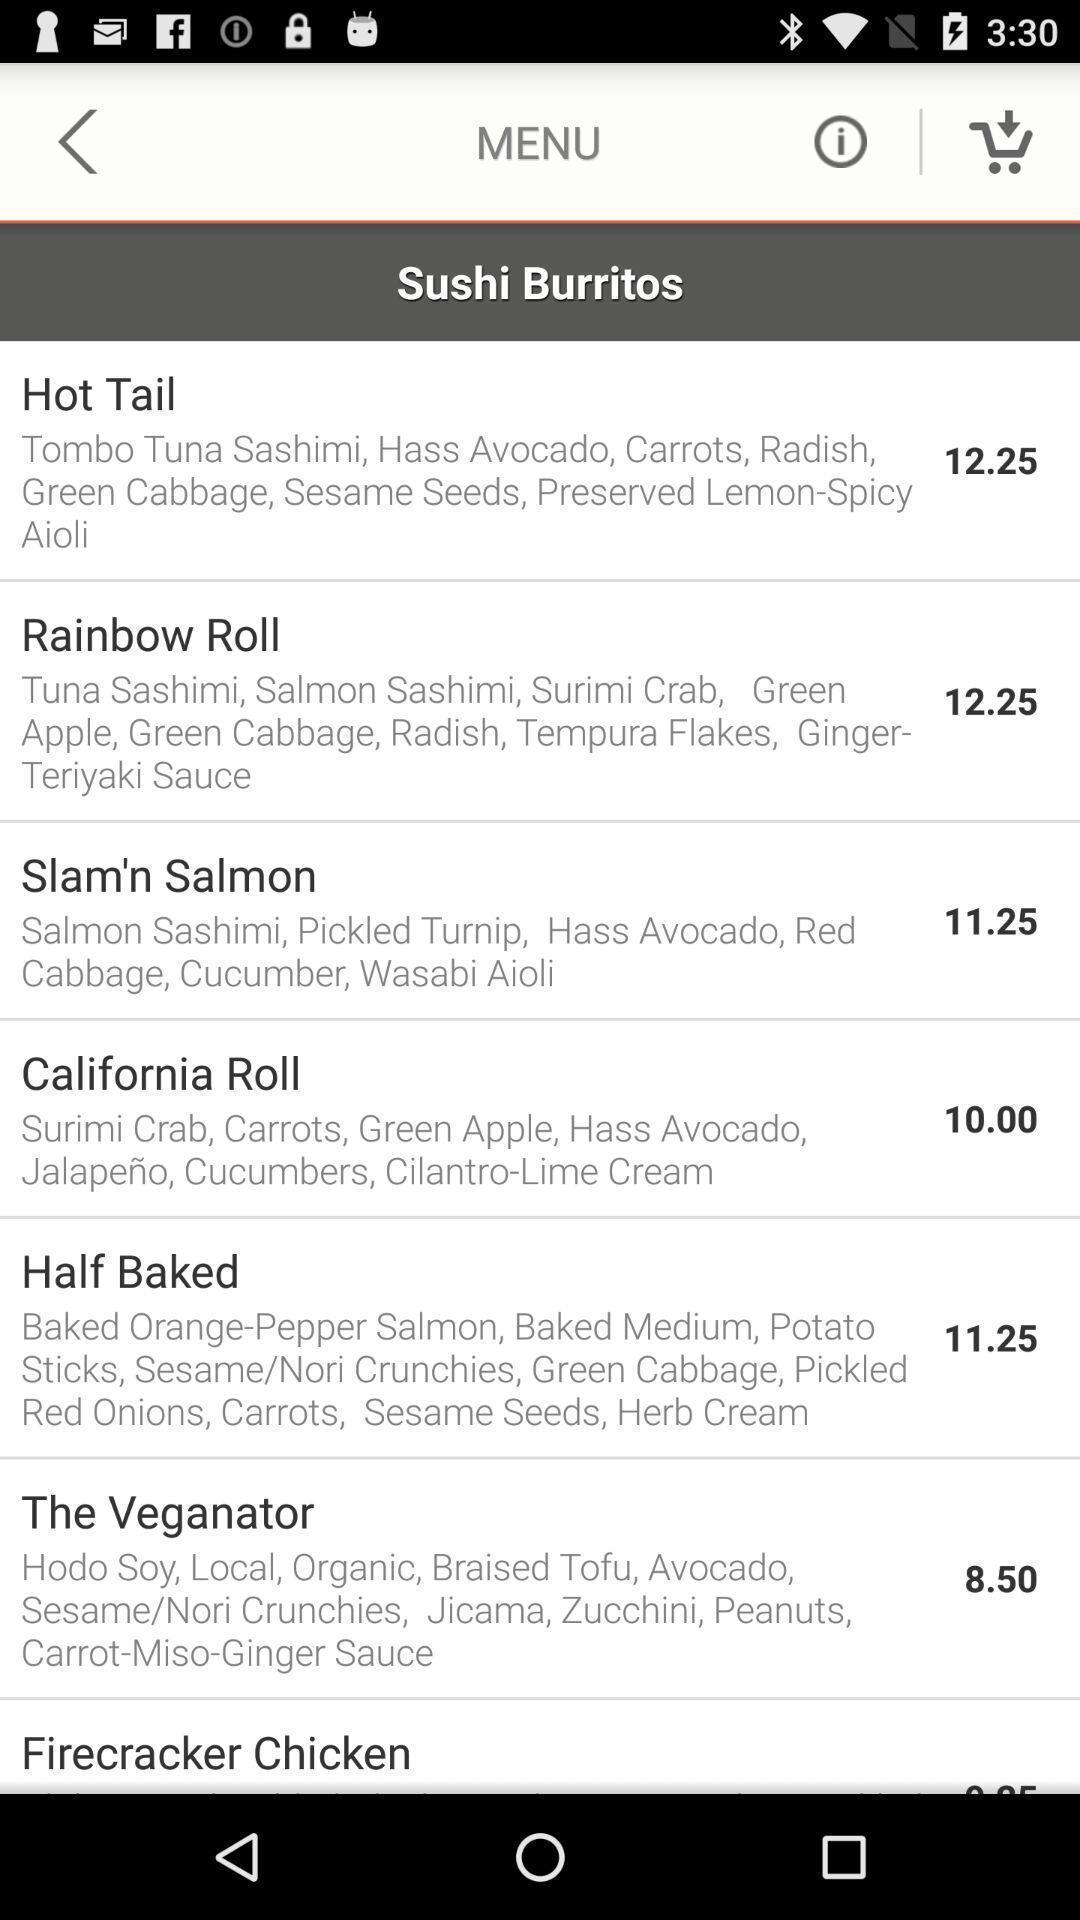Tell me about the visual elements in this screen capture. Screen displaying menu of food items with description. 